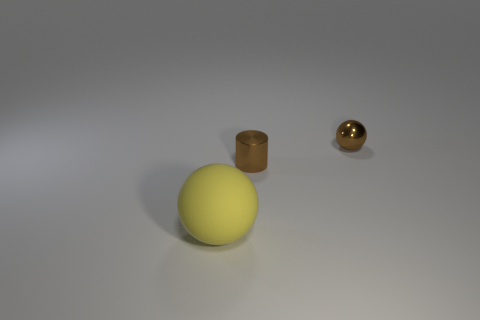Add 1 yellow matte things. How many objects exist? 4 Add 1 tiny cylinders. How many tiny cylinders are left? 2 Add 2 cyan shiny blocks. How many cyan shiny blocks exist? 2 Subtract 0 blue spheres. How many objects are left? 3 Subtract all spheres. How many objects are left? 1 Subtract 2 balls. How many balls are left? 0 Subtract all brown spheres. Subtract all yellow blocks. How many spheres are left? 1 Subtract all big yellow rubber objects. Subtract all large yellow matte cubes. How many objects are left? 2 